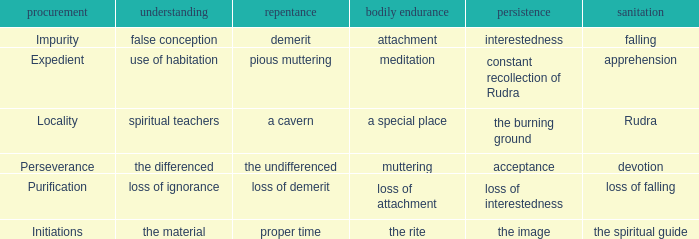What is the total number of constancy where purity is falling 1.0. 